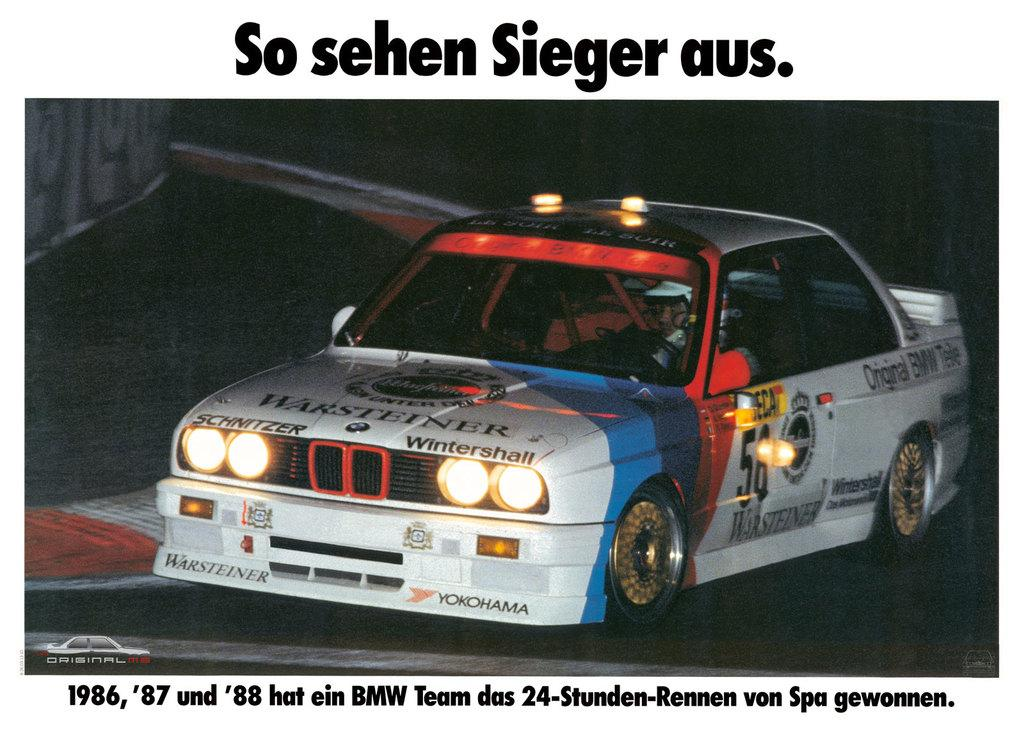What is the main subject of the poster in the image? The main subject of the poster in the image is a car. What else can be seen on the poster besides the car? There is text written on the poster. What type of trousers is the family wearing in the image? There is no family or trousers present in the image; it only features a poster of a car with text. 